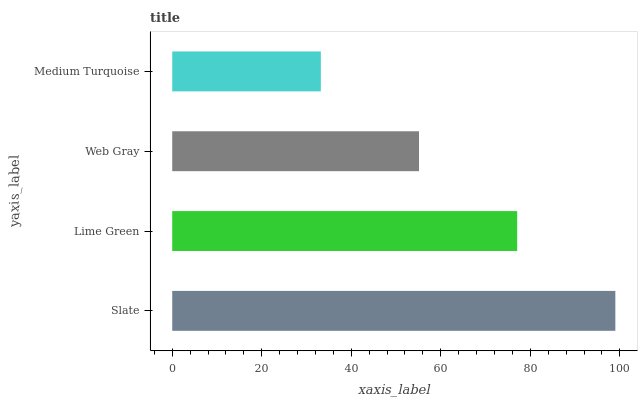Is Medium Turquoise the minimum?
Answer yes or no. Yes. Is Slate the maximum?
Answer yes or no. Yes. Is Lime Green the minimum?
Answer yes or no. No. Is Lime Green the maximum?
Answer yes or no. No. Is Slate greater than Lime Green?
Answer yes or no. Yes. Is Lime Green less than Slate?
Answer yes or no. Yes. Is Lime Green greater than Slate?
Answer yes or no. No. Is Slate less than Lime Green?
Answer yes or no. No. Is Lime Green the high median?
Answer yes or no. Yes. Is Web Gray the low median?
Answer yes or no. Yes. Is Slate the high median?
Answer yes or no. No. Is Medium Turquoise the low median?
Answer yes or no. No. 